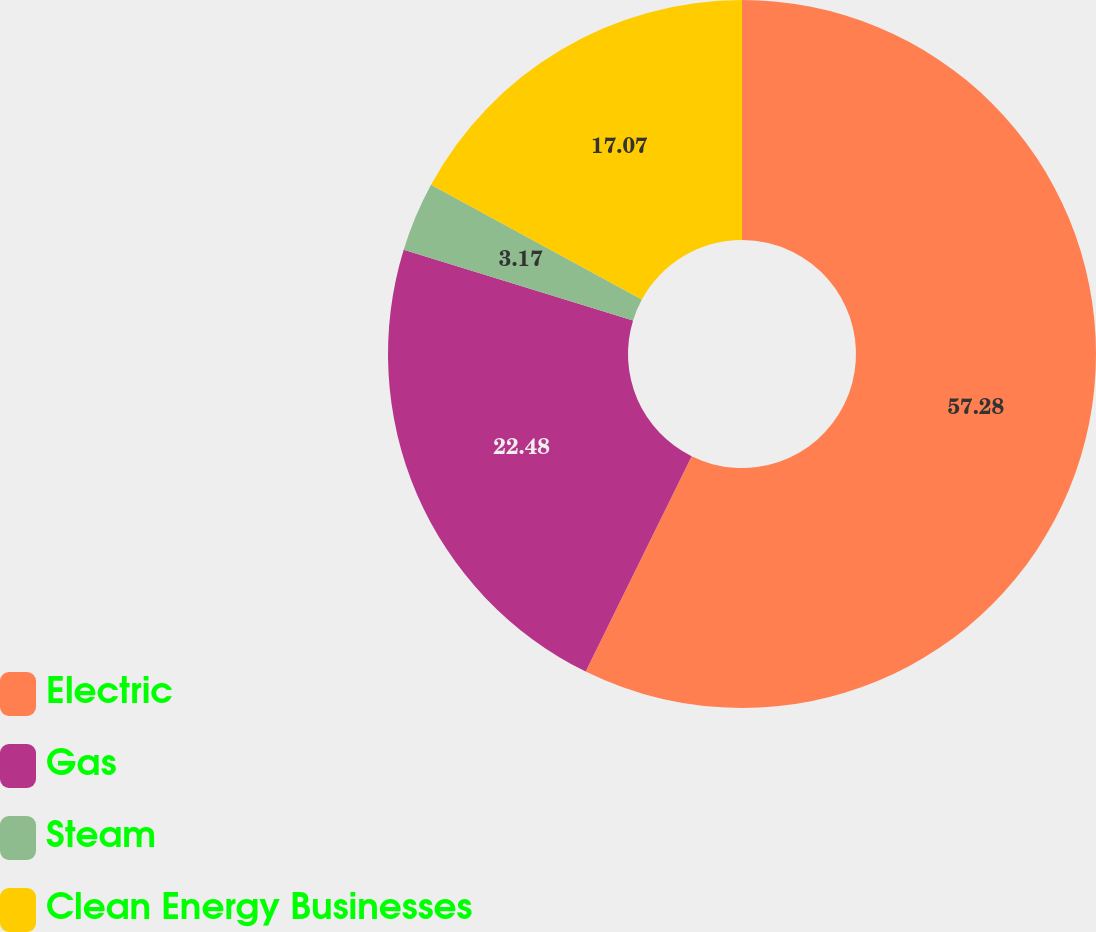Convert chart to OTSL. <chart><loc_0><loc_0><loc_500><loc_500><pie_chart><fcel>Electric<fcel>Gas<fcel>Steam<fcel>Clean Energy Businesses<nl><fcel>57.28%<fcel>22.48%<fcel>3.17%<fcel>17.07%<nl></chart> 